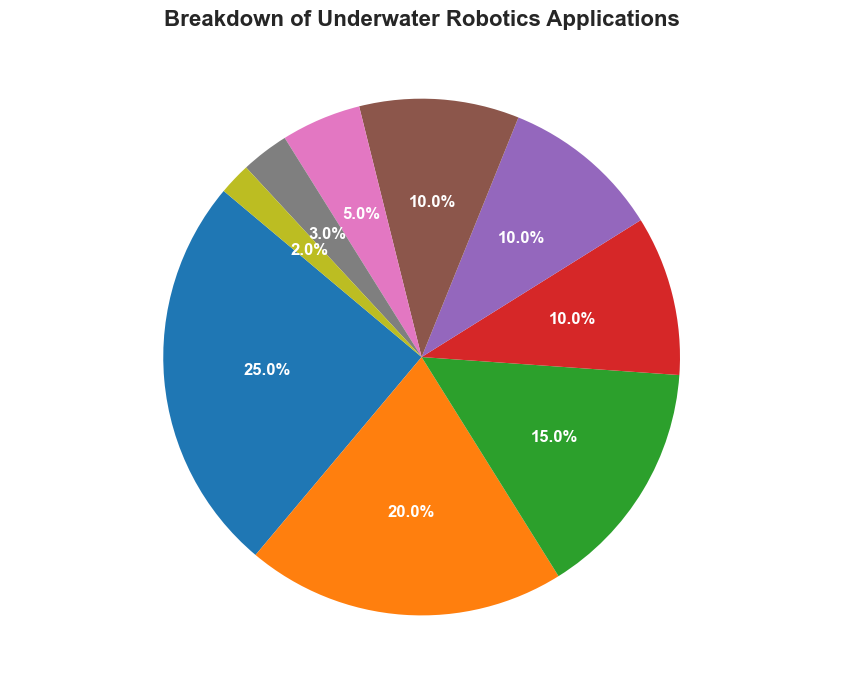Which category has the highest percentage in the pie chart? We need to identify the category with the greatest percentage. The chart shows Scientific Research at 25%, which is the highest value.
Answer: Scientific Research Which two categories have the same percentage? We need to find categories with identical percentages. Marine Biology and Search and Rescue Operations both show a percentage of 10%.
Answer: Marine Biology, Search and Rescue Operations What is the combined percentage of Underwater Exploration and Treasure Hunting? To get the combined percentage, sum the percentages for Underwater Exploration (20%) and Treasure Hunting (3%). 20% + 3% = 23%
Answer: 23% Which application category covers the smallest percentage and how much is it? Identify the category with the smallest percentage. Underwater Archeology has the smallest at 2%.
Answer: Underwater Archeology, 2% How much more percentage is allocated to Scientific Research compared to Oil and Gas Industry? Subtract the percentage of Oil and Gas Industry (10%) from Scientific Research (25%): 25% - 10% = 15%
Answer: 15% What is the total percentage of applications related to Marine Biology, Aquaculture, and Underwater Archeology combined? Sum the percentages for Marine Biology (10%), Aquaculture (5%), and Underwater Archeology (2%): 10% + 5% + 2% = 17%
Answer: 17% Is the percentage for Military and Defense greater or less than for Search and Rescue Operations? Compare the percentages. Military and Defense is 15%, while Search and Rescue Operations is 10%. 15% > 10%, so Military and Defense is greater.
Answer: Greater How many categories have a percentage greater than or equal to 10%? Count the categories where the percentage is ≥ 10%. These are Scientific Research (25%), Underwater Exploration (20%), Military and Defense (15%), Search and Rescue Operations (10%), and Marine Biology (10%). There are 5 such categories.
Answer: 5 What color is used for the category with the lowest percentage? Observe the color assigned to Underwater Archeology, the smallest category at 2%.
Answer: (The specified color from the pie chart without coding details, e.g. 'green' or 'blue') 